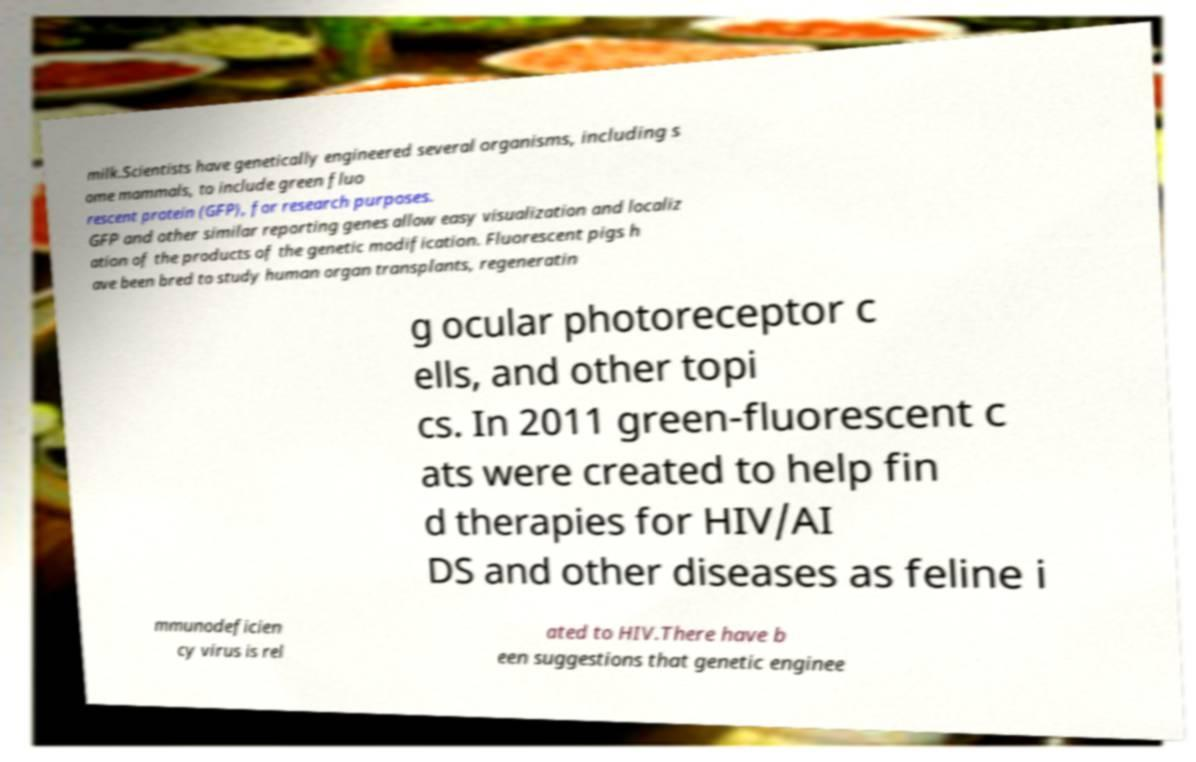Could you assist in decoding the text presented in this image and type it out clearly? milk.Scientists have genetically engineered several organisms, including s ome mammals, to include green fluo rescent protein (GFP), for research purposes. GFP and other similar reporting genes allow easy visualization and localiz ation of the products of the genetic modification. Fluorescent pigs h ave been bred to study human organ transplants, regeneratin g ocular photoreceptor c ells, and other topi cs. In 2011 green-fluorescent c ats were created to help fin d therapies for HIV/AI DS and other diseases as feline i mmunodeficien cy virus is rel ated to HIV.There have b een suggestions that genetic enginee 